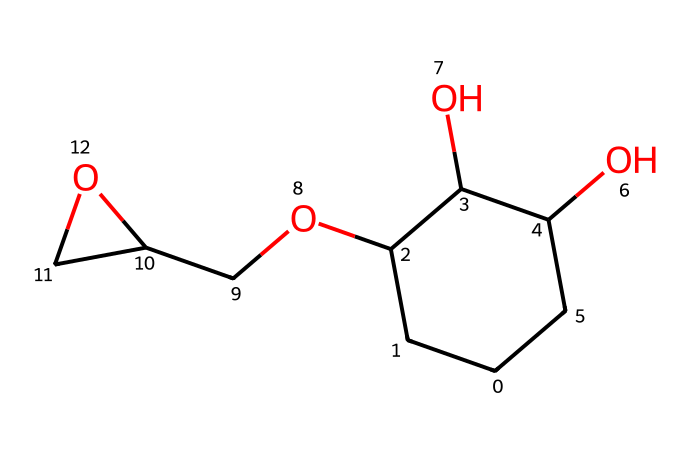What is the total number of carbon atoms in this molecule? The SMILES representation indicates there are 5 carbon atoms from the chain and the branched structure. We can count each carbon individually.
Answer: 5 How many hydroxyl (–OH) groups are present in this compound? A careful examination of the SMILES shows that there are three OH groups indicated by ‘O’ following the carbon chains in the structure.
Answer: 3 What type of polymer does this molecule represent? This structure represents an epoxy resin, which is characterized by the presence of oxirane rings in its composition.
Answer: epoxy resin Which elements are present in this molecular structure? By analyzing the SMILES representation, it is evident that the molecule contains carbon (C), hydrogen (H), and oxygen (O) atoms.
Answer: carbon, hydrogen, oxygen What characteristic suggests that this epoxy resin has good bonding properties? The numerous hydroxyl groups in the molecular structure are indicative of potential for strong hydrogen bonding and adhesion, which enhances bonding properties.
Answer: hydrogen bonding What feature of this epoxy resin makes it suitable for ceramics? The presence of multiple hydroxyl groups allows for excellent adhesion to surfaces, making it suitable for bonding ceramic components in model train kits.
Answer: excellent adhesion 